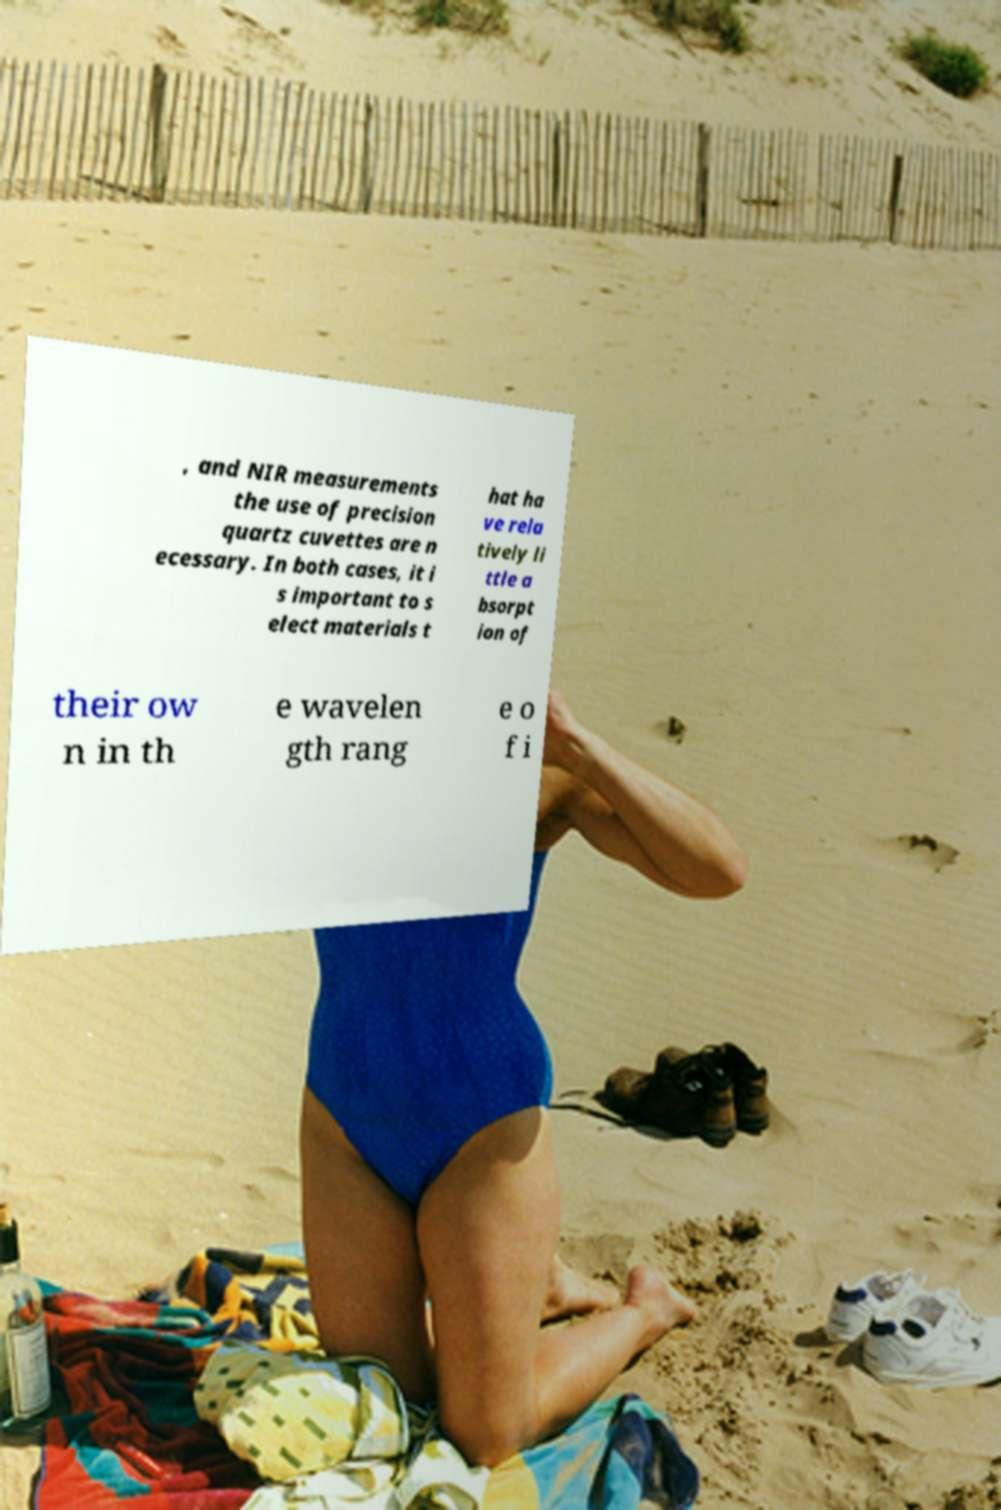Can you accurately transcribe the text from the provided image for me? , and NIR measurements the use of precision quartz cuvettes are n ecessary. In both cases, it i s important to s elect materials t hat ha ve rela tively li ttle a bsorpt ion of their ow n in th e wavelen gth rang e o f i 